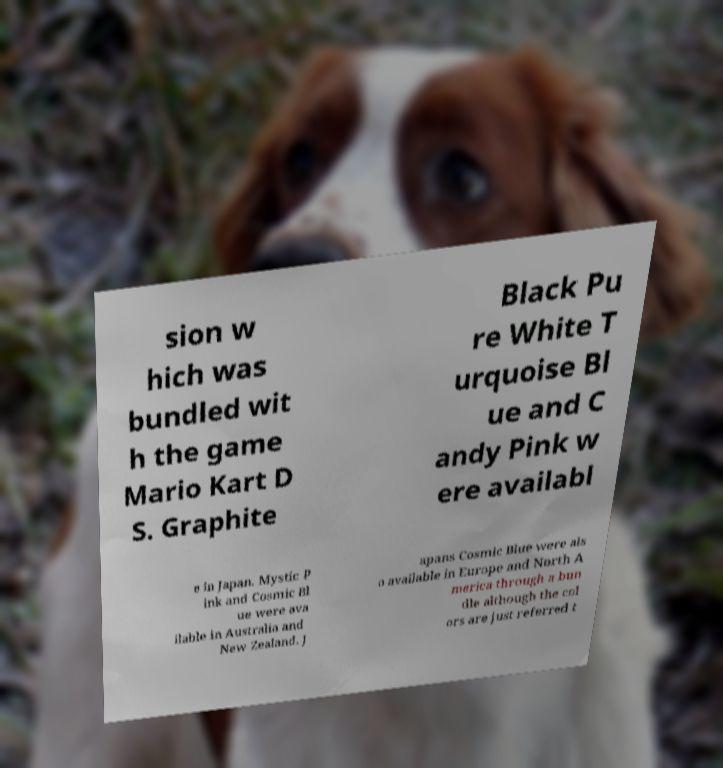Could you extract and type out the text from this image? sion w hich was bundled wit h the game Mario Kart D S. Graphite Black Pu re White T urquoise Bl ue and C andy Pink w ere availabl e in Japan. Mystic P ink and Cosmic Bl ue were ava ilable in Australia and New Zealand. J apans Cosmic Blue were als o available in Europe and North A merica through a bun dle although the col ors are just referred t 